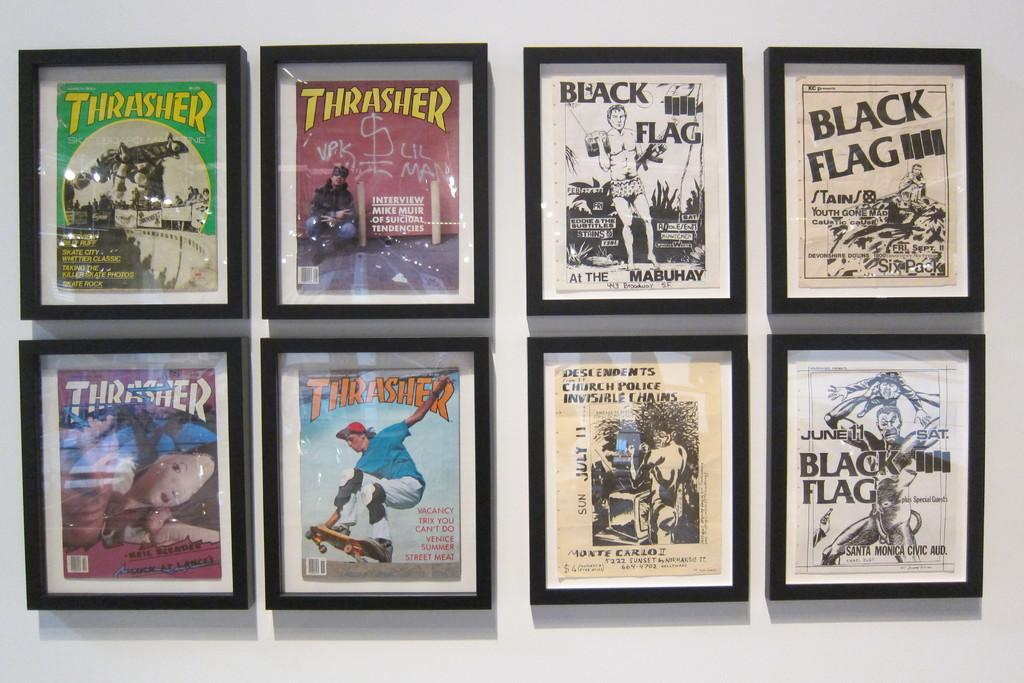<image>
Share a concise interpretation of the image provided. Four issues of Thrasher magazine hang on a wall near some black and white ads. 